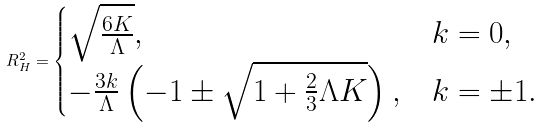<formula> <loc_0><loc_0><loc_500><loc_500>R _ { H } ^ { 2 } = \begin{cases} \sqrt { \frac { 6 K } { \Lambda } } , & k = 0 , \\ - \frac { 3 k } { \Lambda } \left ( - 1 \pm \sqrt { 1 + \frac { 2 } { 3 } \Lambda K } \right ) , & k = \pm 1 . \end{cases}</formula> 